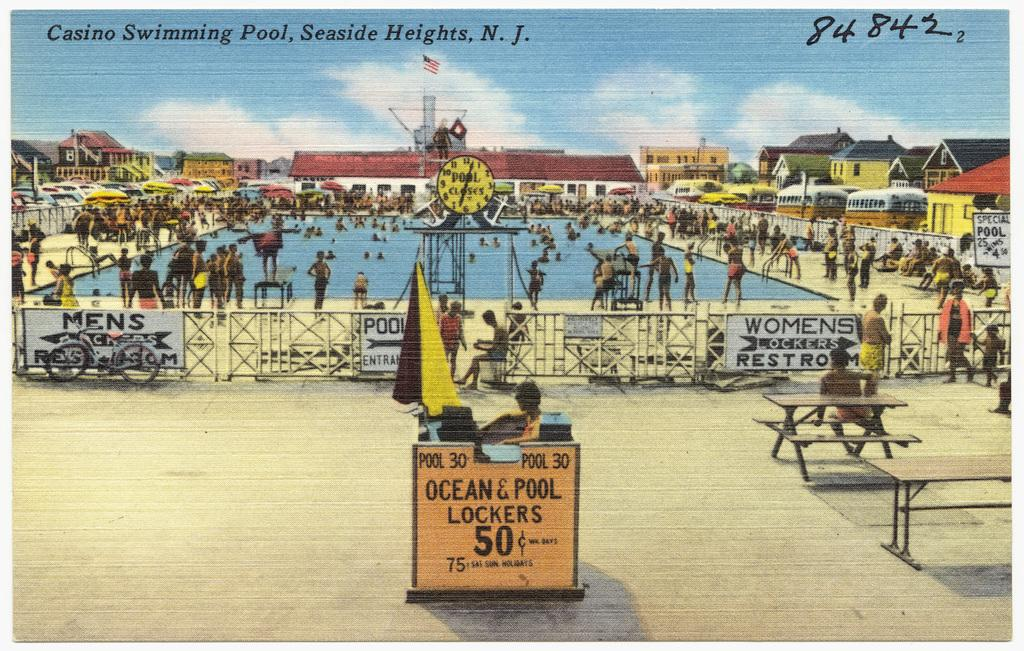Provide a one-sentence caption for the provided image. A postcard of Casino Swimming Pool in New Jersey. 